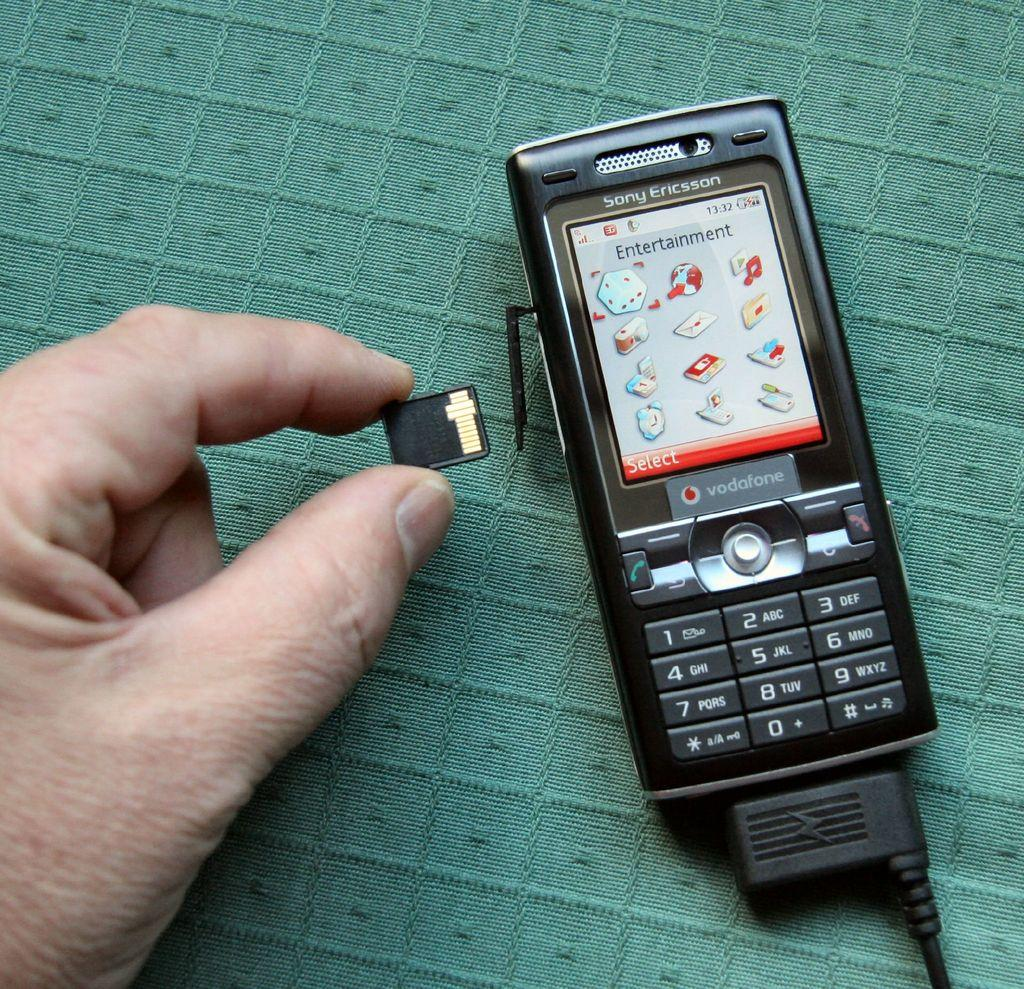Provide a one-sentence caption for the provided image. A vodofone cell phone sits on a green background. 